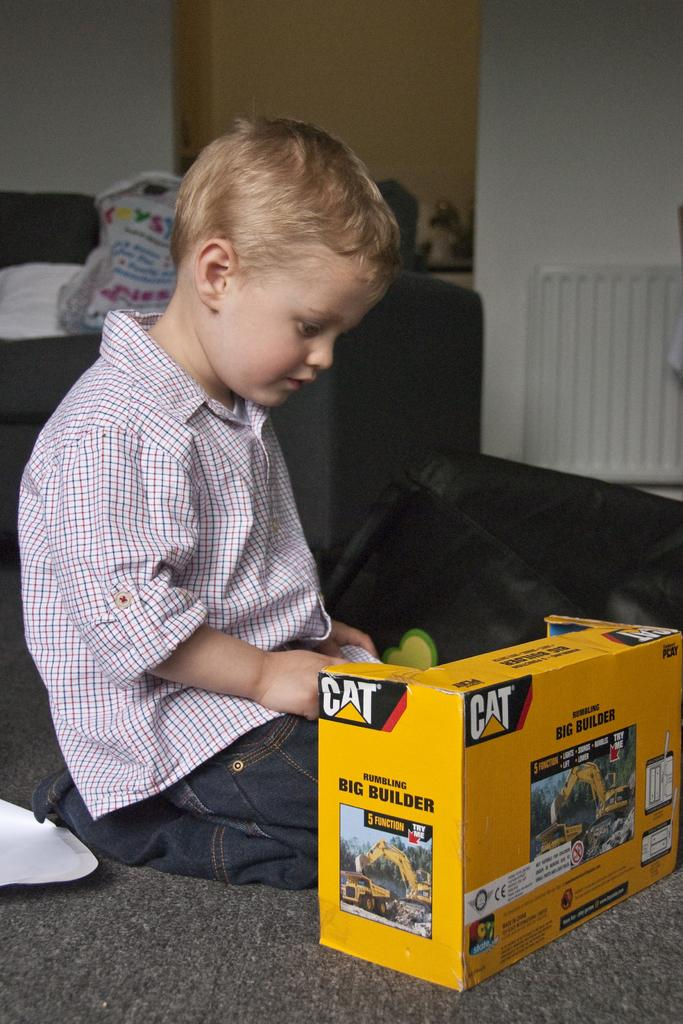Provide a one-sentence caption for the provided image. a young boy playing with a CAT big builder toy. 